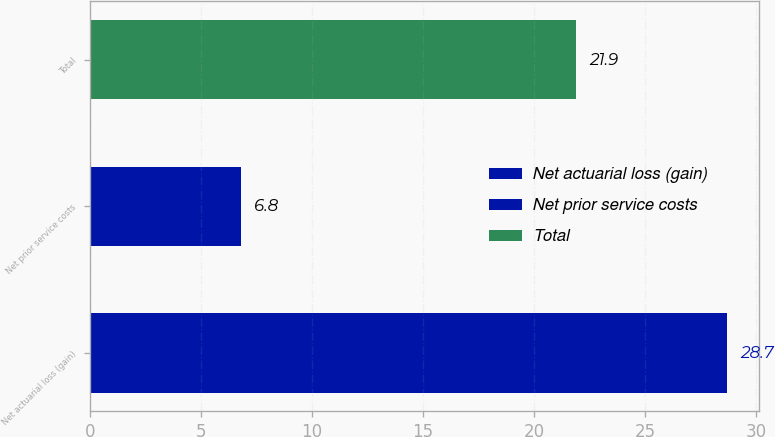<chart> <loc_0><loc_0><loc_500><loc_500><bar_chart><fcel>Net actuarial loss (gain)<fcel>Net prior service costs<fcel>Total<nl><fcel>28.7<fcel>6.8<fcel>21.9<nl></chart> 